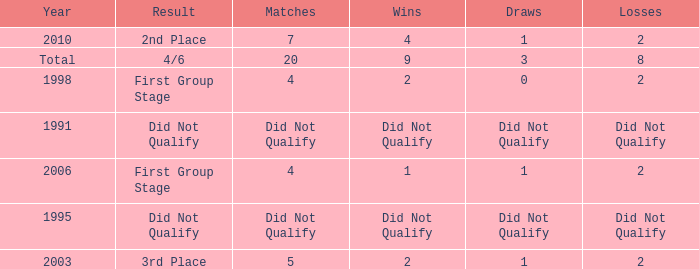What were the matches where the teams finished in the first group stage, in 1998? 4.0. 